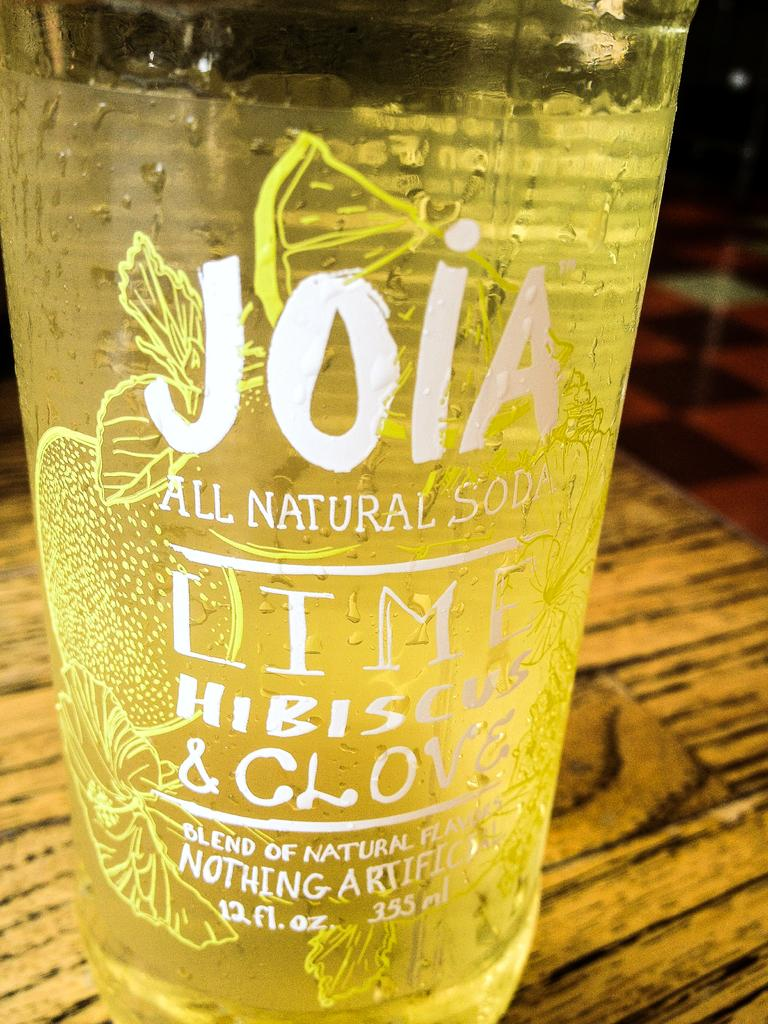<image>
Offer a succinct explanation of the picture presented. A bottle of Joia all natural soda has 12 fl oz. 